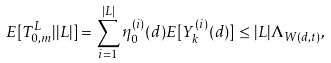Convert formula to latex. <formula><loc_0><loc_0><loc_500><loc_500>E [ T _ { 0 , m } ^ { L } | | L | ] = \sum _ { i = 1 } ^ { | L | } \eta _ { 0 } ^ { ( i ) } ( d ) E [ Y _ { k } ^ { ( i ) } ( d ) ] \leq | L | \Lambda _ { W ( d , t ) } ,</formula> 